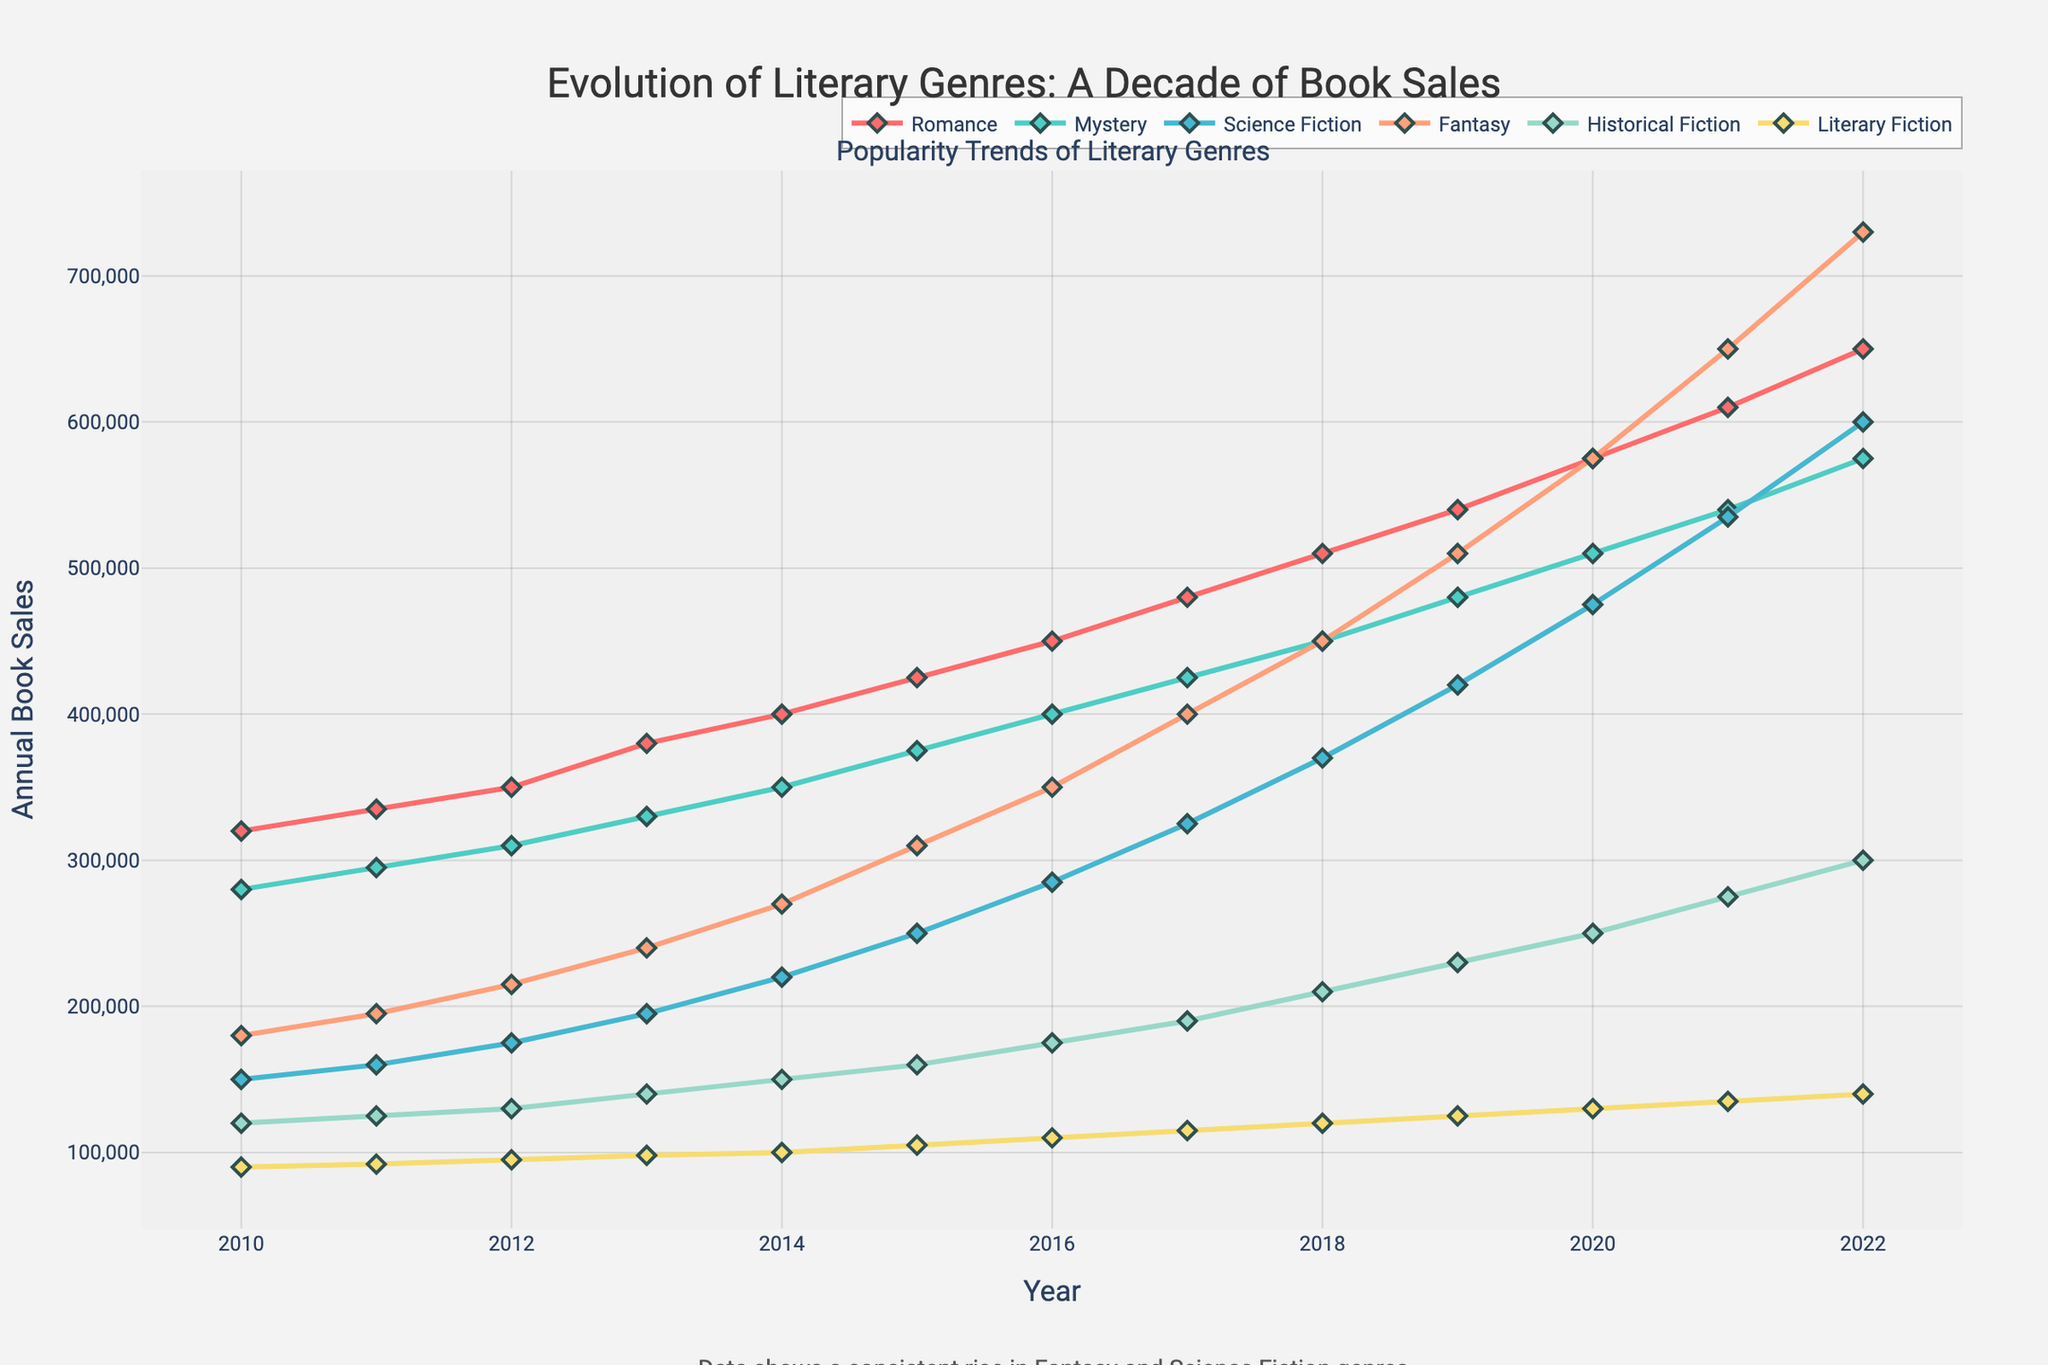What is the total book sales for the Romance genre from 2010 to 2022? To find the total book sales for the Romance genre, sum the sales from each year: 320,000 + 335,000 + 350,000 + 380,000 + 400,000 + 425,000 + 450,000 + 480,000 + 510,000 + 540,000 + 575,000 + 610,000 + 650,000 = 6,025,000
Answer: 6,025,000 Which genre showed the highest increase in annual book sales from 2010 to 2022? To determine which genre showed the highest increase, calculate the difference in book sales from 2010 to 2022 for each genre and compare: 
Romance: 650,000 - 320,000 = 330,000
Mystery: 575,000 - 280,000 = 295,000
Science Fiction: 600,000 - 150,000 = 450,000
Fantasy: 730,000 - 180,000 = 550,000
Historical Fiction: 300,000 - 120,000 = 180,000
Literary Fiction: 140,000 - 90,000 = 50,000
Fantasy has the highest increase with 550,000
Answer: Fantasy Among Mystery and Science Fiction, which genre had a higher book sales growth rate from 2010 to 2022? Growth rate is calculated by (final sales - initial sales) / initial sales.
Mystery: (575,000 - 280,000) / 280,000 = 1.05
Science Fiction: (600,000 - 150,000) / 150,000 = 3.00
Science Fiction had a higher growth rate.
Answer: Science Fiction In which year did the Fantasy genre surpass the sales of the Mystery genre? Compare the sales of Fantasy and Mystery year by year until Fantasy's sales become higher:
2010: Fantasy (180,000) < Mystery (280,000)
2011: Fantasy (195,000) < Mystery (295,000)
2012: Fantasy (215,000) < Mystery (310,000)
2013: Fantasy (240,000) < Mystery (330,000)
2014: Fantasy (270,000) < Mystery (350,000)
2015: Fantasy (310,000) < Mystery (375,000)
2016: Fantasy (350,000) < Mystery (400,000)
2017: Fantasy (400,000) < Mystery (425,000)
2018: Fantasy (450,000) = Mystery (450,000)
2019: Fantasy (510,000) > Mystery (480,000)
Fantasy surpassed Mystery in 2019.
Answer: 2019 Which year recorded the highest annual book sales for Literary Fiction? Observing the data for Literary Fiction, the highest sales occur in:
2010: 90,000
2011: 92,000
2012: 95,000
2013: 98,000
2014: 100,000
2015: 105,000
2016: 110,000
2017: 115,000
2018: 120,000
2019: 125,000
2020: 130,000
2021: 135,000
2022: 140,000
The highest annual book sales were in 2022.
Answer: 2022 What is the difference in annual book sales between the Literary Fiction and Historical Fiction genres in 2022? Calculate the difference in sales for these genres in 2022: 
Historical Fiction: 300,000
Literary Fiction: 140,000
Difference: 300,000 - 140,000 = 160,000
Answer: 160,000 Which genre had the smallest increase in annual book sales from 2010 to 2022? Calculate the increase in book sales for each genre:
Romance: 650,000 - 320,000 = 330,000
Mystery: 575,000 - 280,000 = 295,000
Science Fiction: 600,000 - 150,000 = 450,000
Fantasy: 730,000 - 180,000 = 550,000
Historical Fiction: 300,000 - 120,000 = 180,000
Literary Fiction: 140,000 - 90,000 = 50,000
Literary Fiction had the smallest increase with 50,000.
Answer: Literary Fiction Which genre's sales visually peaked in 2016? By looking at the trend lines, the genres that visually peaked in 2016 can be determined. However, all genres show continuing increasing trends in 2016 without peaking. None of the genre's sales peaked in 2016.
Answer: None 